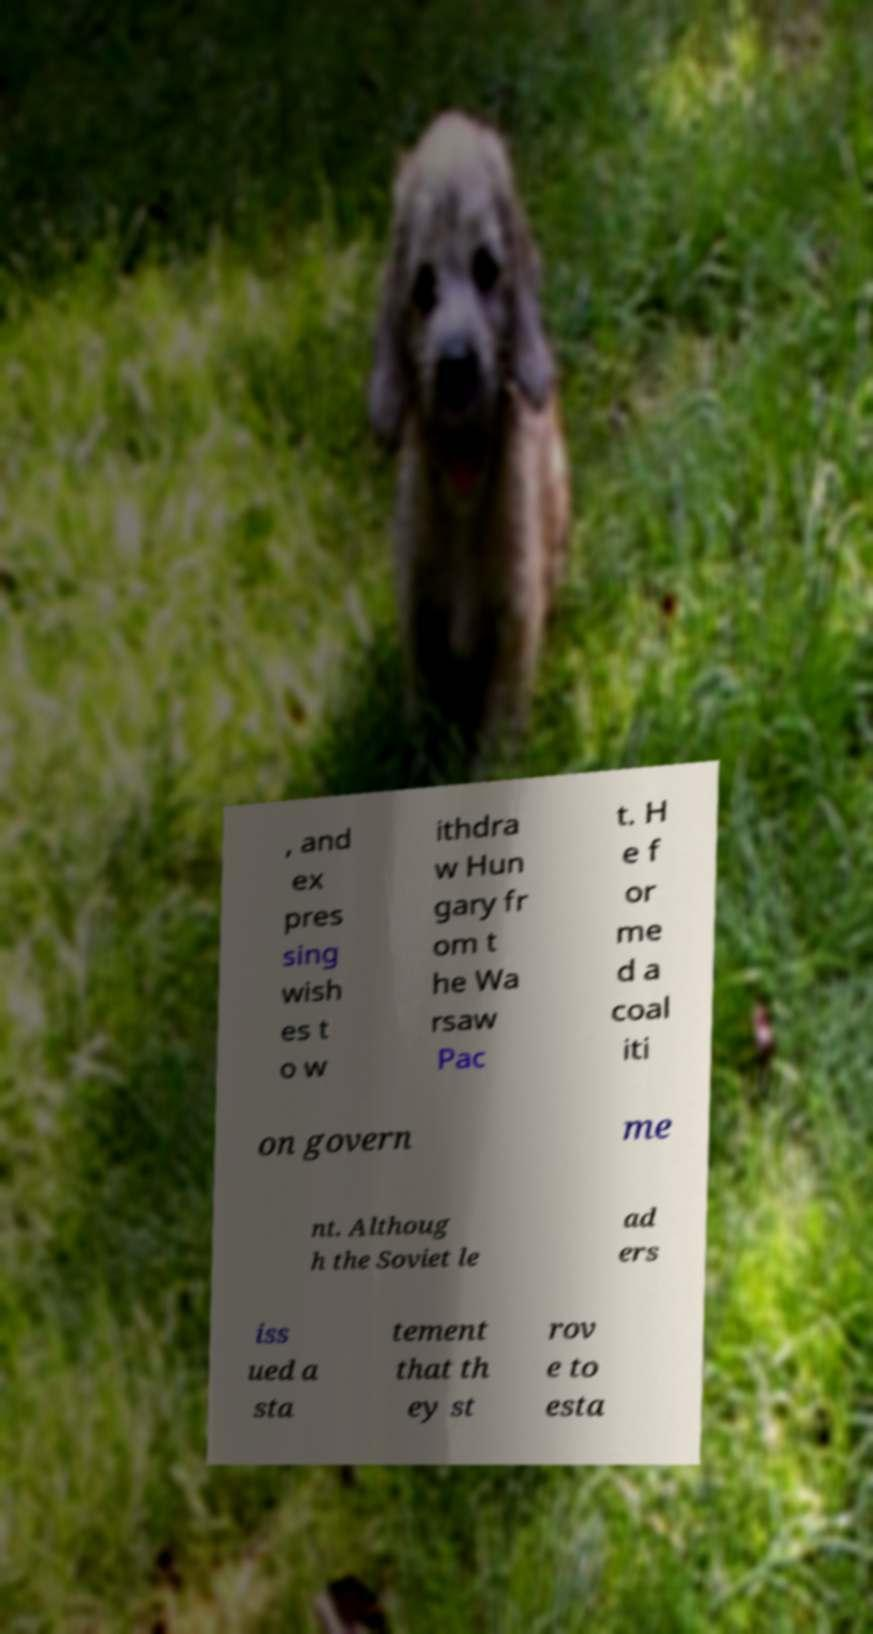Could you extract and type out the text from this image? , and ex pres sing wish es t o w ithdra w Hun gary fr om t he Wa rsaw Pac t. H e f or me d a coal iti on govern me nt. Althoug h the Soviet le ad ers iss ued a sta tement that th ey st rov e to esta 